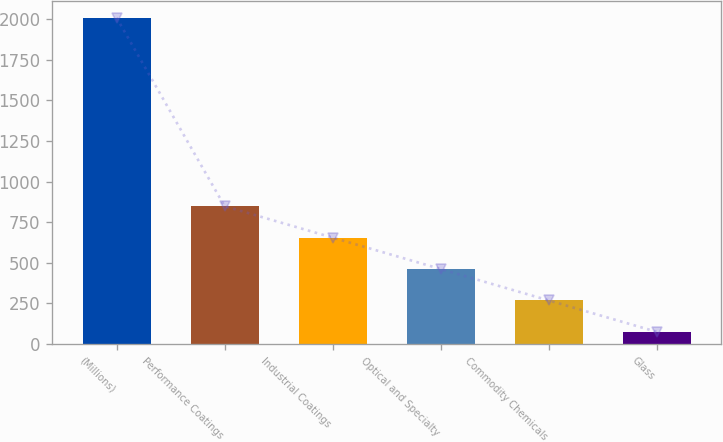Convert chart to OTSL. <chart><loc_0><loc_0><loc_500><loc_500><bar_chart><fcel>(Millions)<fcel>Performance Coatings<fcel>Industrial Coatings<fcel>Optical and Specialty<fcel>Commodity Chemicals<fcel>Glass<nl><fcel>2010<fcel>848.4<fcel>654.8<fcel>461.2<fcel>267.6<fcel>74<nl></chart> 